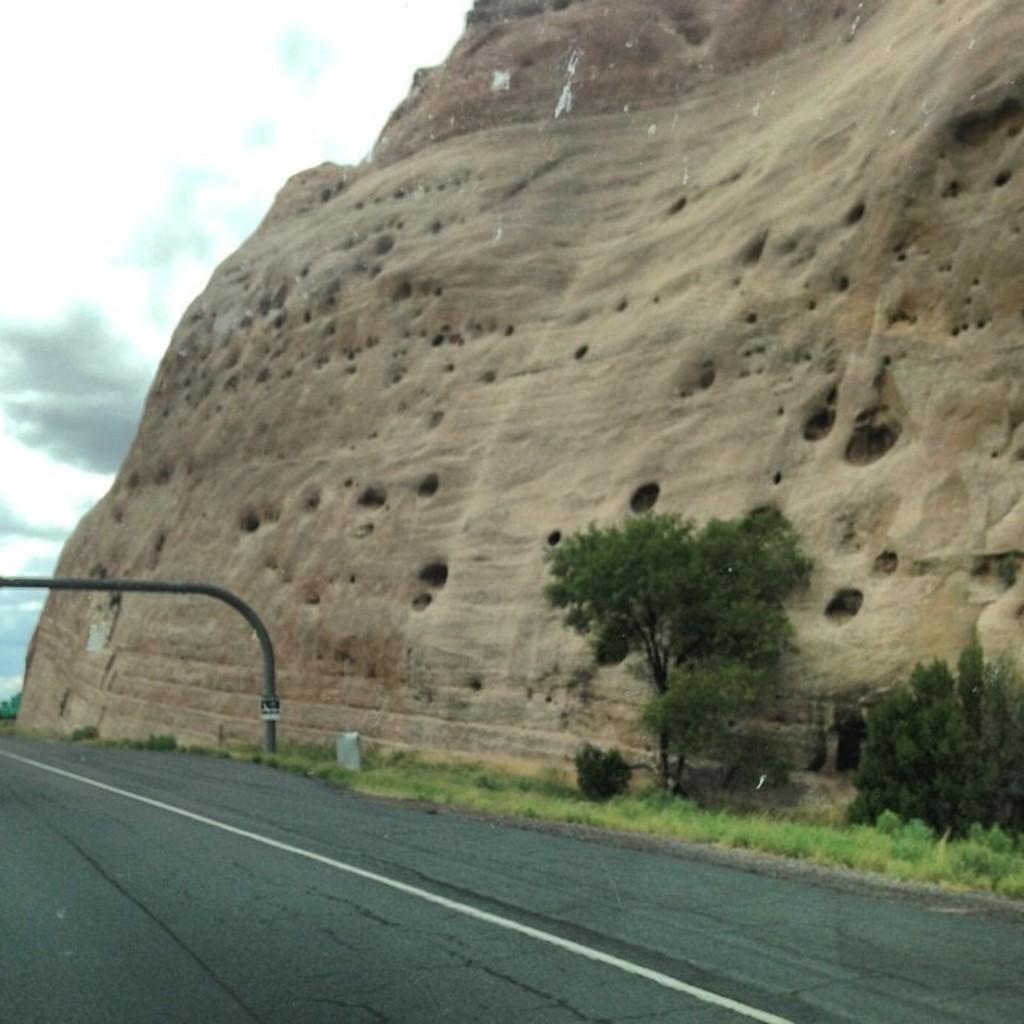Could you give a brief overview of what you see in this image? We can see road,grass,trees and rod and we can see rock. In the background we can see sky with clouds. 